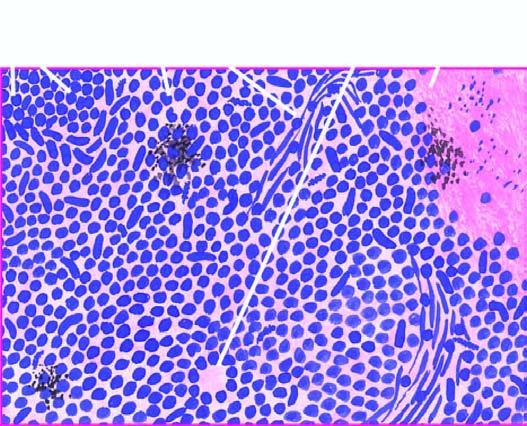re the alveoli and respiratory bronchioles surrounding the coal macule arranged in sheets, cords or aggregates and at places form pseudorosettes?
Answer the question using a single word or phrase. No 